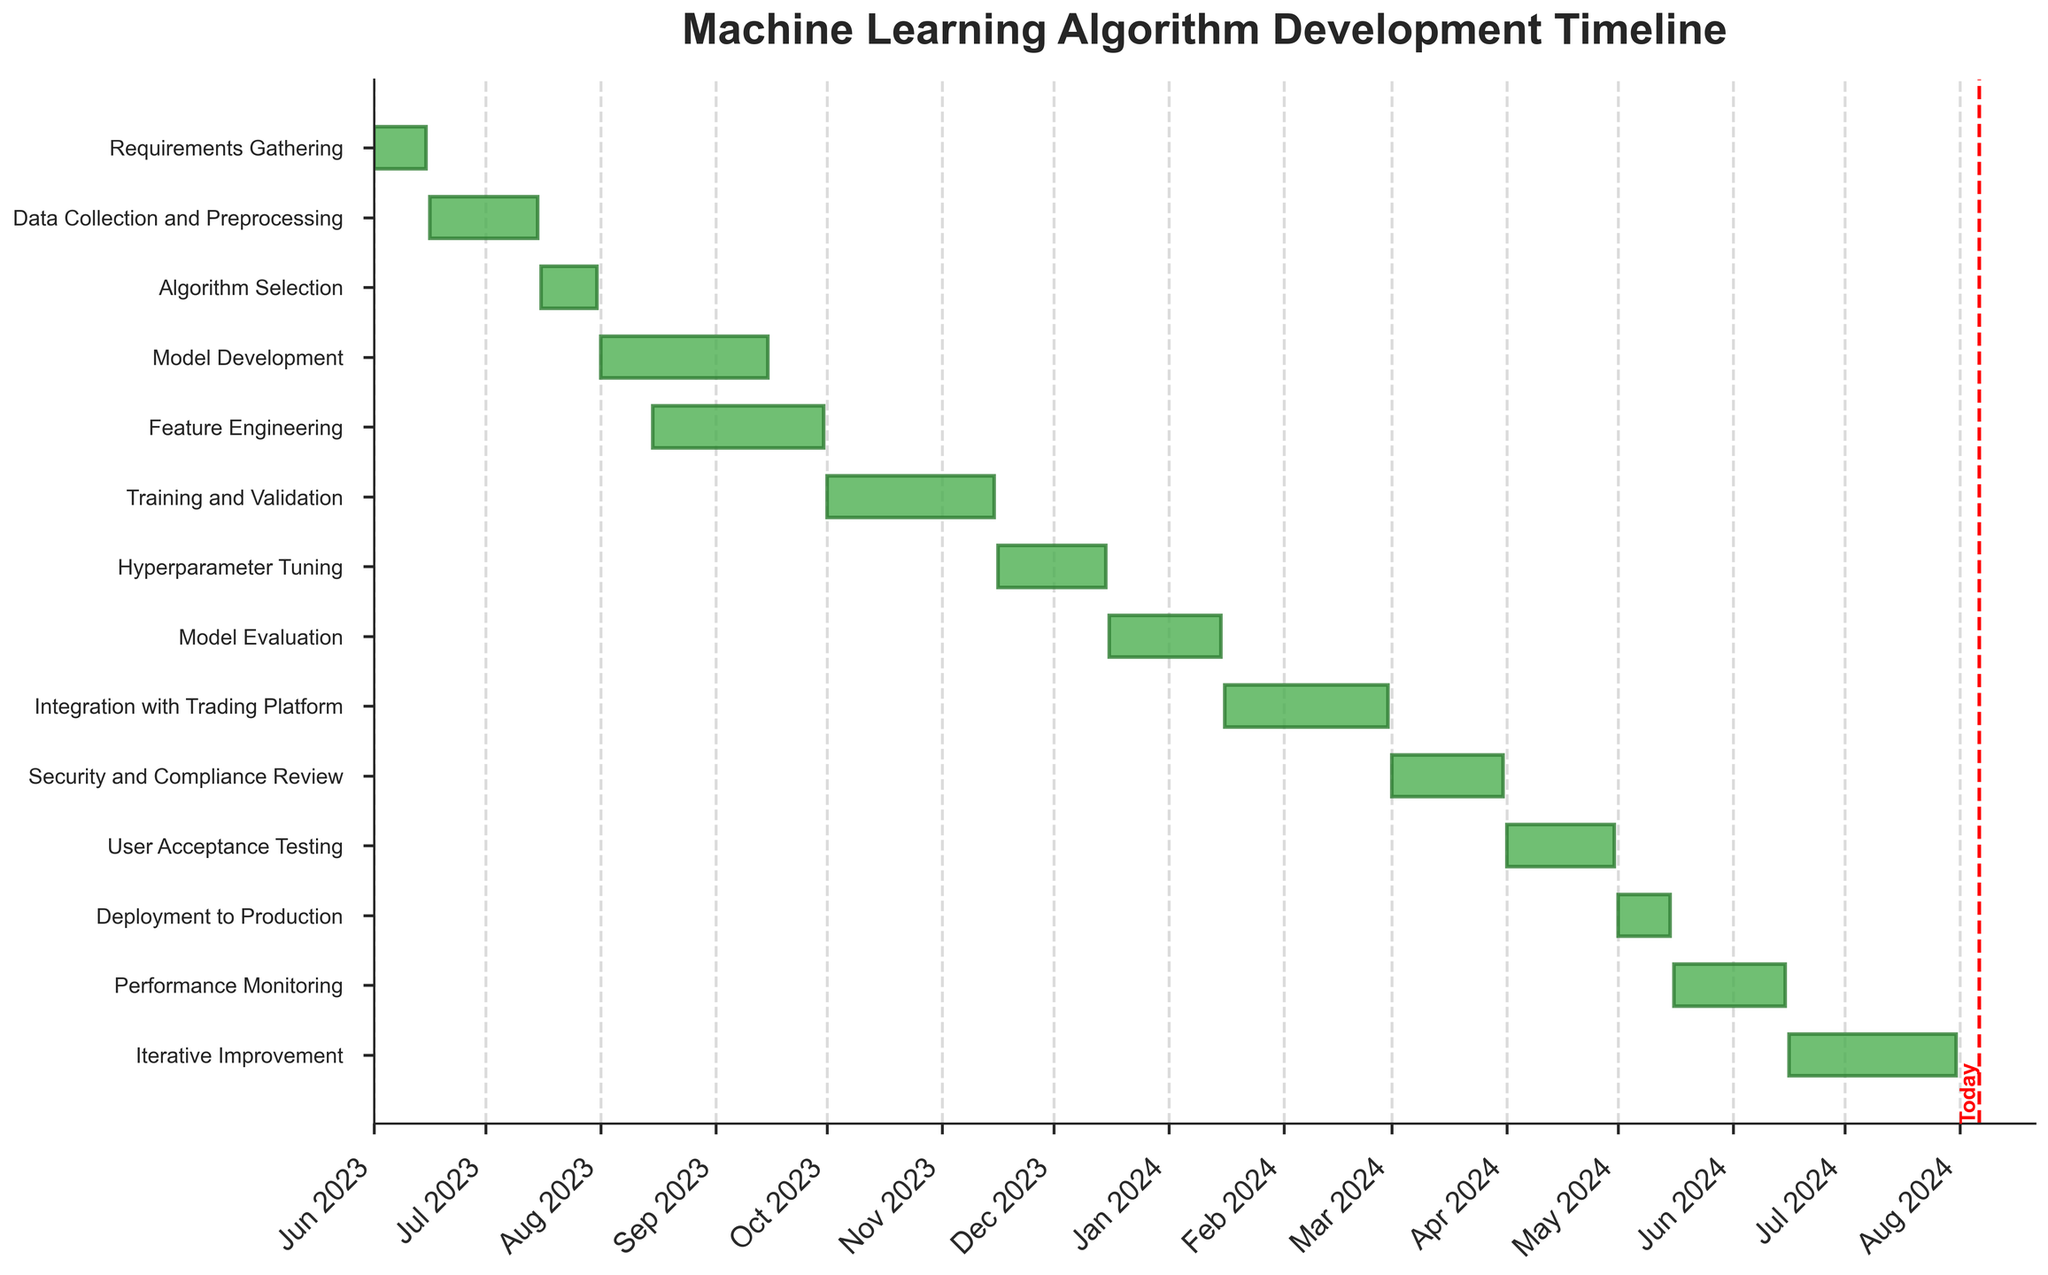which task starts right after the end of the 'Requirements Gathering' stage? The 'Requirements Gathering' stage ends on 2023-06-15, and the task that starts on 2023-06-16 is 'Data Collection and Preprocessing'.
Answer: Data Collection and Preprocessing How long does the 'Training and Validation' stage last? The 'Training and Validation' stage starts on 2023-10-01 and ends on 2023-11-15. This duration is calculated by subtracting the start date from the end date, resulting in 45 days.
Answer: 45 days What is the time overlap between 'Model Development' and 'Feature Engineering'? 'Model Development' starts on 2023-08-01 and ends on 2023-09-15, while 'Feature Engineering' starts on 2023-08-15 and ends on 2023-09-30. The overlap is from 2023-08-15 to 2023-09-15, which is 31 days.
Answer: 31 days Which stage takes the longest time to complete? By comparing the durations of each stage, the longest duration is for 'Iterative Improvement', which lasts from 2024-06-16 to 2024-07-31, resulting in 46 days.
Answer: Iterative Improvement Of the tasks that begin in 2024, which one starts first? By looking at tasks that start in 2024, the earliest one is 'Integration with Trading Platform,' which begins on 2024-01-16.
Answer: Integration with Trading Platform Which stage is directly before 'Deployment to Production'? 'User Acceptance Testing' ends on 2024-04-30, right before 'Deployment to Production' starts on 2024-05-01.
Answer: User Acceptance Testing Which tasks are ongoing today? Today’s date needs to be within the beginning and end dates of the tasks. For example, if today is 2023-12-01, the ongoing tasks would include 'Model Evaluation', which runs from 2023-12-16 to 2024-01-15.
Answer: Model Evaluation (assuming today is 2023-12-01) Are there any stages that take exactly one month (30 or 31 days)? By examining the durations, we see that 'Hyperparameter Tuning' lasts from 2023-11-16 to 2023-12-15, which is 30 days.
Answer: Hyperparameter Tuning 